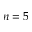<formula> <loc_0><loc_0><loc_500><loc_500>n = 5</formula> 